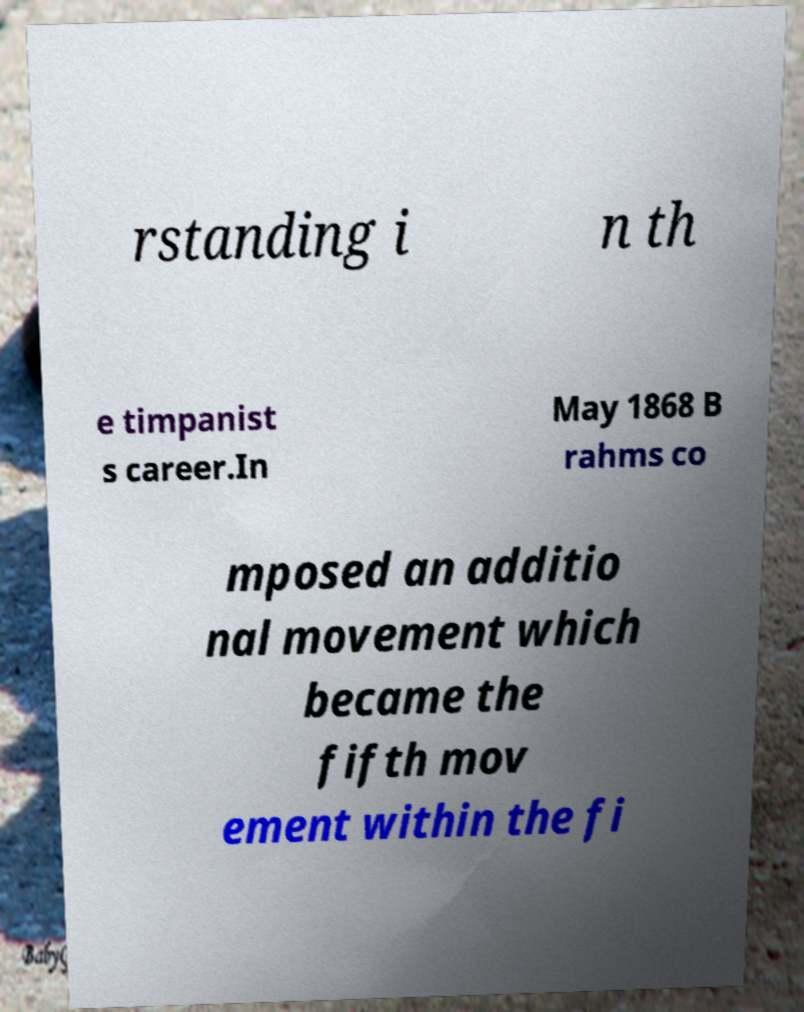What messages or text are displayed in this image? I need them in a readable, typed format. rstanding i n th e timpanist s career.In May 1868 B rahms co mposed an additio nal movement which became the fifth mov ement within the fi 